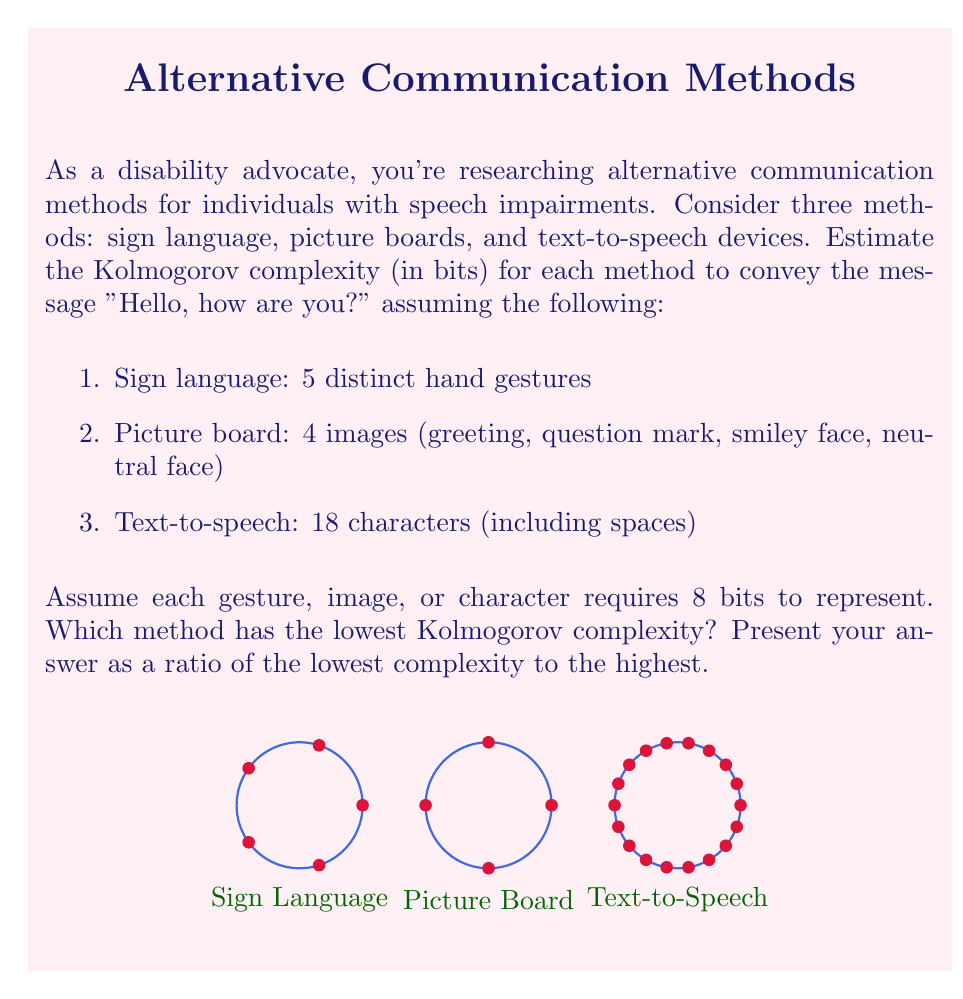Provide a solution to this math problem. To solve this problem, we need to calculate the Kolmogorov complexity for each method and then compare them. The Kolmogorov complexity is an estimate of the minimum number of bits required to represent the information.

1. Sign language:
   - 5 distinct hand gestures
   - Each gesture requires 8 bits
   - Total bits: $5 \times 8 = 40$ bits

2. Picture board:
   - 4 images
   - Each image requires 8 bits
   - Total bits: $4 \times 8 = 32$ bits

3. Text-to-speech:
   - 18 characters (including spaces)
   - Each character requires 8 bits
   - Total bits: $18 \times 8 = 144$ bits

Comparing the complexities:
- Sign language: 40 bits
- Picture board: 32 bits
- Text-to-speech: 144 bits

The method with the lowest Kolmogorov complexity is the picture board (32 bits), and the highest is text-to-speech (144 bits).

To express the answer as a ratio of the lowest complexity to the highest:

$$\frac{\text{Lowest complexity}}{\text{Highest complexity}} = \frac{32}{144} = \frac{2}{9} \approx 0.2222$$

This ratio can be simplified to 2:9.
Answer: 2:9 